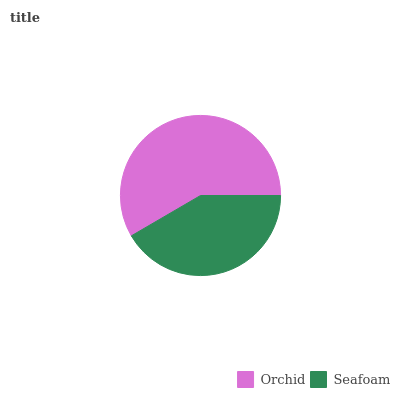Is Seafoam the minimum?
Answer yes or no. Yes. Is Orchid the maximum?
Answer yes or no. Yes. Is Seafoam the maximum?
Answer yes or no. No. Is Orchid greater than Seafoam?
Answer yes or no. Yes. Is Seafoam less than Orchid?
Answer yes or no. Yes. Is Seafoam greater than Orchid?
Answer yes or no. No. Is Orchid less than Seafoam?
Answer yes or no. No. Is Orchid the high median?
Answer yes or no. Yes. Is Seafoam the low median?
Answer yes or no. Yes. Is Seafoam the high median?
Answer yes or no. No. Is Orchid the low median?
Answer yes or no. No. 